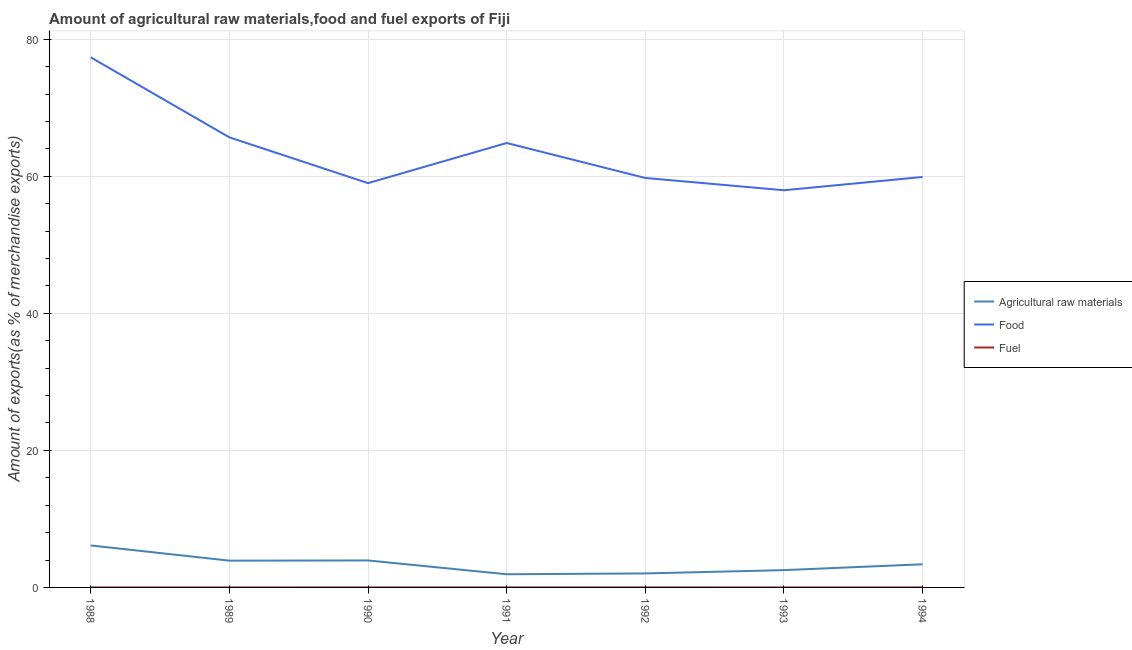How many different coloured lines are there?
Give a very brief answer. 3. Does the line corresponding to percentage of food exports intersect with the line corresponding to percentage of raw materials exports?
Offer a terse response. No. What is the percentage of raw materials exports in 1992?
Keep it short and to the point. 2.04. Across all years, what is the maximum percentage of raw materials exports?
Provide a short and direct response. 6.13. Across all years, what is the minimum percentage of raw materials exports?
Give a very brief answer. 1.92. In which year was the percentage of fuel exports maximum?
Keep it short and to the point. 1991. What is the total percentage of fuel exports in the graph?
Make the answer very short. 0.01. What is the difference between the percentage of fuel exports in 1988 and that in 1993?
Make the answer very short. -0. What is the difference between the percentage of fuel exports in 1988 and the percentage of food exports in 1989?
Provide a succinct answer. -65.68. What is the average percentage of food exports per year?
Provide a short and direct response. 63.5. In the year 1988, what is the difference between the percentage of fuel exports and percentage of raw materials exports?
Your answer should be compact. -6.13. What is the ratio of the percentage of fuel exports in 1988 to that in 1994?
Your answer should be very brief. 0.27. What is the difference between the highest and the second highest percentage of food exports?
Offer a terse response. 11.68. What is the difference between the highest and the lowest percentage of raw materials exports?
Your answer should be very brief. 4.2. Is the sum of the percentage of food exports in 1988 and 1994 greater than the maximum percentage of fuel exports across all years?
Your response must be concise. Yes. How many lines are there?
Give a very brief answer. 3. Are the values on the major ticks of Y-axis written in scientific E-notation?
Provide a succinct answer. No. Does the graph contain any zero values?
Offer a very short reply. No. Does the graph contain grids?
Your response must be concise. Yes. How many legend labels are there?
Offer a terse response. 3. How are the legend labels stacked?
Keep it short and to the point. Vertical. What is the title of the graph?
Give a very brief answer. Amount of agricultural raw materials,food and fuel exports of Fiji. What is the label or title of the X-axis?
Give a very brief answer. Year. What is the label or title of the Y-axis?
Offer a terse response. Amount of exports(as % of merchandise exports). What is the Amount of exports(as % of merchandise exports) of Agricultural raw materials in 1988?
Provide a short and direct response. 6.13. What is the Amount of exports(as % of merchandise exports) of Food in 1988?
Give a very brief answer. 77.36. What is the Amount of exports(as % of merchandise exports) of Fuel in 1988?
Give a very brief answer. 0. What is the Amount of exports(as % of merchandise exports) of Agricultural raw materials in 1989?
Offer a very short reply. 3.91. What is the Amount of exports(as % of merchandise exports) in Food in 1989?
Give a very brief answer. 65.68. What is the Amount of exports(as % of merchandise exports) in Fuel in 1989?
Offer a very short reply. 3.98845700657726e-5. What is the Amount of exports(as % of merchandise exports) in Agricultural raw materials in 1990?
Keep it short and to the point. 3.94. What is the Amount of exports(as % of merchandise exports) of Food in 1990?
Offer a terse response. 59. What is the Amount of exports(as % of merchandise exports) in Fuel in 1990?
Your response must be concise. 0. What is the Amount of exports(as % of merchandise exports) in Agricultural raw materials in 1991?
Your answer should be very brief. 1.92. What is the Amount of exports(as % of merchandise exports) of Food in 1991?
Offer a very short reply. 64.85. What is the Amount of exports(as % of merchandise exports) in Fuel in 1991?
Your answer should be compact. 0. What is the Amount of exports(as % of merchandise exports) of Agricultural raw materials in 1992?
Keep it short and to the point. 2.04. What is the Amount of exports(as % of merchandise exports) in Food in 1992?
Give a very brief answer. 59.75. What is the Amount of exports(as % of merchandise exports) in Fuel in 1992?
Offer a terse response. 0. What is the Amount of exports(as % of merchandise exports) of Agricultural raw materials in 1993?
Offer a very short reply. 2.53. What is the Amount of exports(as % of merchandise exports) in Food in 1993?
Provide a succinct answer. 57.96. What is the Amount of exports(as % of merchandise exports) in Fuel in 1993?
Your answer should be very brief. 0. What is the Amount of exports(as % of merchandise exports) in Agricultural raw materials in 1994?
Keep it short and to the point. 3.38. What is the Amount of exports(as % of merchandise exports) of Food in 1994?
Keep it short and to the point. 59.9. What is the Amount of exports(as % of merchandise exports) in Fuel in 1994?
Make the answer very short. 0. Across all years, what is the maximum Amount of exports(as % of merchandise exports) of Agricultural raw materials?
Your response must be concise. 6.13. Across all years, what is the maximum Amount of exports(as % of merchandise exports) in Food?
Give a very brief answer. 77.36. Across all years, what is the maximum Amount of exports(as % of merchandise exports) in Fuel?
Provide a succinct answer. 0. Across all years, what is the minimum Amount of exports(as % of merchandise exports) of Agricultural raw materials?
Offer a very short reply. 1.92. Across all years, what is the minimum Amount of exports(as % of merchandise exports) in Food?
Provide a short and direct response. 57.96. Across all years, what is the minimum Amount of exports(as % of merchandise exports) of Fuel?
Give a very brief answer. 3.98845700657726e-5. What is the total Amount of exports(as % of merchandise exports) in Agricultural raw materials in the graph?
Keep it short and to the point. 23.84. What is the total Amount of exports(as % of merchandise exports) in Food in the graph?
Give a very brief answer. 444.5. What is the total Amount of exports(as % of merchandise exports) of Fuel in the graph?
Keep it short and to the point. 0.01. What is the difference between the Amount of exports(as % of merchandise exports) in Agricultural raw materials in 1988 and that in 1989?
Your response must be concise. 2.22. What is the difference between the Amount of exports(as % of merchandise exports) of Food in 1988 and that in 1989?
Your answer should be compact. 11.68. What is the difference between the Amount of exports(as % of merchandise exports) in Agricultural raw materials in 1988 and that in 1990?
Provide a succinct answer. 2.19. What is the difference between the Amount of exports(as % of merchandise exports) of Food in 1988 and that in 1990?
Your answer should be very brief. 18.36. What is the difference between the Amount of exports(as % of merchandise exports) in Fuel in 1988 and that in 1990?
Make the answer very short. -0. What is the difference between the Amount of exports(as % of merchandise exports) in Agricultural raw materials in 1988 and that in 1991?
Provide a succinct answer. 4.2. What is the difference between the Amount of exports(as % of merchandise exports) in Food in 1988 and that in 1991?
Keep it short and to the point. 12.5. What is the difference between the Amount of exports(as % of merchandise exports) of Fuel in 1988 and that in 1991?
Provide a succinct answer. -0. What is the difference between the Amount of exports(as % of merchandise exports) of Agricultural raw materials in 1988 and that in 1992?
Offer a very short reply. 4.08. What is the difference between the Amount of exports(as % of merchandise exports) of Food in 1988 and that in 1992?
Your answer should be compact. 17.6. What is the difference between the Amount of exports(as % of merchandise exports) of Fuel in 1988 and that in 1992?
Give a very brief answer. -0. What is the difference between the Amount of exports(as % of merchandise exports) of Agricultural raw materials in 1988 and that in 1993?
Offer a very short reply. 3.6. What is the difference between the Amount of exports(as % of merchandise exports) of Food in 1988 and that in 1993?
Ensure brevity in your answer.  19.4. What is the difference between the Amount of exports(as % of merchandise exports) in Fuel in 1988 and that in 1993?
Your answer should be compact. -0. What is the difference between the Amount of exports(as % of merchandise exports) in Agricultural raw materials in 1988 and that in 1994?
Make the answer very short. 2.75. What is the difference between the Amount of exports(as % of merchandise exports) of Food in 1988 and that in 1994?
Your response must be concise. 17.46. What is the difference between the Amount of exports(as % of merchandise exports) of Fuel in 1988 and that in 1994?
Offer a very short reply. -0. What is the difference between the Amount of exports(as % of merchandise exports) in Agricultural raw materials in 1989 and that in 1990?
Offer a terse response. -0.03. What is the difference between the Amount of exports(as % of merchandise exports) of Food in 1989 and that in 1990?
Make the answer very short. 6.68. What is the difference between the Amount of exports(as % of merchandise exports) of Fuel in 1989 and that in 1990?
Keep it short and to the point. -0. What is the difference between the Amount of exports(as % of merchandise exports) of Agricultural raw materials in 1989 and that in 1991?
Keep it short and to the point. 1.98. What is the difference between the Amount of exports(as % of merchandise exports) in Food in 1989 and that in 1991?
Provide a short and direct response. 0.83. What is the difference between the Amount of exports(as % of merchandise exports) in Fuel in 1989 and that in 1991?
Make the answer very short. -0. What is the difference between the Amount of exports(as % of merchandise exports) in Agricultural raw materials in 1989 and that in 1992?
Offer a very short reply. 1.86. What is the difference between the Amount of exports(as % of merchandise exports) of Food in 1989 and that in 1992?
Your answer should be compact. 5.93. What is the difference between the Amount of exports(as % of merchandise exports) in Fuel in 1989 and that in 1992?
Ensure brevity in your answer.  -0. What is the difference between the Amount of exports(as % of merchandise exports) of Agricultural raw materials in 1989 and that in 1993?
Keep it short and to the point. 1.38. What is the difference between the Amount of exports(as % of merchandise exports) in Food in 1989 and that in 1993?
Your response must be concise. 7.72. What is the difference between the Amount of exports(as % of merchandise exports) in Fuel in 1989 and that in 1993?
Give a very brief answer. -0. What is the difference between the Amount of exports(as % of merchandise exports) in Agricultural raw materials in 1989 and that in 1994?
Keep it short and to the point. 0.53. What is the difference between the Amount of exports(as % of merchandise exports) in Food in 1989 and that in 1994?
Offer a terse response. 5.78. What is the difference between the Amount of exports(as % of merchandise exports) in Fuel in 1989 and that in 1994?
Your answer should be compact. -0. What is the difference between the Amount of exports(as % of merchandise exports) of Agricultural raw materials in 1990 and that in 1991?
Your answer should be very brief. 2.01. What is the difference between the Amount of exports(as % of merchandise exports) of Food in 1990 and that in 1991?
Your response must be concise. -5.86. What is the difference between the Amount of exports(as % of merchandise exports) of Fuel in 1990 and that in 1991?
Give a very brief answer. -0. What is the difference between the Amount of exports(as % of merchandise exports) of Agricultural raw materials in 1990 and that in 1992?
Give a very brief answer. 1.89. What is the difference between the Amount of exports(as % of merchandise exports) in Food in 1990 and that in 1992?
Offer a very short reply. -0.75. What is the difference between the Amount of exports(as % of merchandise exports) in Fuel in 1990 and that in 1992?
Offer a terse response. -0. What is the difference between the Amount of exports(as % of merchandise exports) in Agricultural raw materials in 1990 and that in 1993?
Ensure brevity in your answer.  1.41. What is the difference between the Amount of exports(as % of merchandise exports) of Food in 1990 and that in 1993?
Your answer should be compact. 1.04. What is the difference between the Amount of exports(as % of merchandise exports) in Agricultural raw materials in 1990 and that in 1994?
Your answer should be compact. 0.56. What is the difference between the Amount of exports(as % of merchandise exports) of Food in 1990 and that in 1994?
Offer a very short reply. -0.9. What is the difference between the Amount of exports(as % of merchandise exports) of Agricultural raw materials in 1991 and that in 1992?
Your answer should be compact. -0.12. What is the difference between the Amount of exports(as % of merchandise exports) in Food in 1991 and that in 1992?
Your answer should be very brief. 5.1. What is the difference between the Amount of exports(as % of merchandise exports) of Fuel in 1991 and that in 1992?
Your answer should be very brief. 0. What is the difference between the Amount of exports(as % of merchandise exports) in Agricultural raw materials in 1991 and that in 1993?
Your answer should be compact. -0.6. What is the difference between the Amount of exports(as % of merchandise exports) of Food in 1991 and that in 1993?
Your answer should be very brief. 6.9. What is the difference between the Amount of exports(as % of merchandise exports) in Fuel in 1991 and that in 1993?
Provide a short and direct response. 0. What is the difference between the Amount of exports(as % of merchandise exports) in Agricultural raw materials in 1991 and that in 1994?
Make the answer very short. -1.45. What is the difference between the Amount of exports(as % of merchandise exports) of Food in 1991 and that in 1994?
Your answer should be compact. 4.96. What is the difference between the Amount of exports(as % of merchandise exports) in Fuel in 1991 and that in 1994?
Offer a terse response. 0. What is the difference between the Amount of exports(as % of merchandise exports) in Agricultural raw materials in 1992 and that in 1993?
Offer a very short reply. -0.48. What is the difference between the Amount of exports(as % of merchandise exports) in Food in 1992 and that in 1993?
Keep it short and to the point. 1.79. What is the difference between the Amount of exports(as % of merchandise exports) in Fuel in 1992 and that in 1993?
Offer a very short reply. 0. What is the difference between the Amount of exports(as % of merchandise exports) in Agricultural raw materials in 1992 and that in 1994?
Provide a short and direct response. -1.34. What is the difference between the Amount of exports(as % of merchandise exports) in Food in 1992 and that in 1994?
Offer a terse response. -0.15. What is the difference between the Amount of exports(as % of merchandise exports) in Fuel in 1992 and that in 1994?
Give a very brief answer. 0. What is the difference between the Amount of exports(as % of merchandise exports) of Agricultural raw materials in 1993 and that in 1994?
Offer a very short reply. -0.85. What is the difference between the Amount of exports(as % of merchandise exports) of Food in 1993 and that in 1994?
Provide a short and direct response. -1.94. What is the difference between the Amount of exports(as % of merchandise exports) of Agricultural raw materials in 1988 and the Amount of exports(as % of merchandise exports) of Food in 1989?
Offer a very short reply. -59.55. What is the difference between the Amount of exports(as % of merchandise exports) of Agricultural raw materials in 1988 and the Amount of exports(as % of merchandise exports) of Fuel in 1989?
Give a very brief answer. 6.13. What is the difference between the Amount of exports(as % of merchandise exports) in Food in 1988 and the Amount of exports(as % of merchandise exports) in Fuel in 1989?
Provide a succinct answer. 77.36. What is the difference between the Amount of exports(as % of merchandise exports) of Agricultural raw materials in 1988 and the Amount of exports(as % of merchandise exports) of Food in 1990?
Make the answer very short. -52.87. What is the difference between the Amount of exports(as % of merchandise exports) in Agricultural raw materials in 1988 and the Amount of exports(as % of merchandise exports) in Fuel in 1990?
Make the answer very short. 6.12. What is the difference between the Amount of exports(as % of merchandise exports) of Food in 1988 and the Amount of exports(as % of merchandise exports) of Fuel in 1990?
Keep it short and to the point. 77.35. What is the difference between the Amount of exports(as % of merchandise exports) in Agricultural raw materials in 1988 and the Amount of exports(as % of merchandise exports) in Food in 1991?
Give a very brief answer. -58.73. What is the difference between the Amount of exports(as % of merchandise exports) of Agricultural raw materials in 1988 and the Amount of exports(as % of merchandise exports) of Fuel in 1991?
Your answer should be very brief. 6.12. What is the difference between the Amount of exports(as % of merchandise exports) in Food in 1988 and the Amount of exports(as % of merchandise exports) in Fuel in 1991?
Provide a short and direct response. 77.35. What is the difference between the Amount of exports(as % of merchandise exports) in Agricultural raw materials in 1988 and the Amount of exports(as % of merchandise exports) in Food in 1992?
Make the answer very short. -53.63. What is the difference between the Amount of exports(as % of merchandise exports) in Agricultural raw materials in 1988 and the Amount of exports(as % of merchandise exports) in Fuel in 1992?
Your answer should be very brief. 6.12. What is the difference between the Amount of exports(as % of merchandise exports) of Food in 1988 and the Amount of exports(as % of merchandise exports) of Fuel in 1992?
Keep it short and to the point. 77.35. What is the difference between the Amount of exports(as % of merchandise exports) of Agricultural raw materials in 1988 and the Amount of exports(as % of merchandise exports) of Food in 1993?
Your answer should be compact. -51.83. What is the difference between the Amount of exports(as % of merchandise exports) in Agricultural raw materials in 1988 and the Amount of exports(as % of merchandise exports) in Fuel in 1993?
Provide a succinct answer. 6.12. What is the difference between the Amount of exports(as % of merchandise exports) of Food in 1988 and the Amount of exports(as % of merchandise exports) of Fuel in 1993?
Provide a succinct answer. 77.36. What is the difference between the Amount of exports(as % of merchandise exports) in Agricultural raw materials in 1988 and the Amount of exports(as % of merchandise exports) in Food in 1994?
Your answer should be compact. -53.77. What is the difference between the Amount of exports(as % of merchandise exports) in Agricultural raw materials in 1988 and the Amount of exports(as % of merchandise exports) in Fuel in 1994?
Your response must be concise. 6.12. What is the difference between the Amount of exports(as % of merchandise exports) of Food in 1988 and the Amount of exports(as % of merchandise exports) of Fuel in 1994?
Provide a short and direct response. 77.36. What is the difference between the Amount of exports(as % of merchandise exports) in Agricultural raw materials in 1989 and the Amount of exports(as % of merchandise exports) in Food in 1990?
Your response must be concise. -55.09. What is the difference between the Amount of exports(as % of merchandise exports) in Agricultural raw materials in 1989 and the Amount of exports(as % of merchandise exports) in Fuel in 1990?
Offer a terse response. 3.9. What is the difference between the Amount of exports(as % of merchandise exports) in Food in 1989 and the Amount of exports(as % of merchandise exports) in Fuel in 1990?
Your answer should be compact. 65.68. What is the difference between the Amount of exports(as % of merchandise exports) in Agricultural raw materials in 1989 and the Amount of exports(as % of merchandise exports) in Food in 1991?
Keep it short and to the point. -60.95. What is the difference between the Amount of exports(as % of merchandise exports) in Agricultural raw materials in 1989 and the Amount of exports(as % of merchandise exports) in Fuel in 1991?
Your response must be concise. 3.9. What is the difference between the Amount of exports(as % of merchandise exports) in Food in 1989 and the Amount of exports(as % of merchandise exports) in Fuel in 1991?
Your answer should be very brief. 65.68. What is the difference between the Amount of exports(as % of merchandise exports) of Agricultural raw materials in 1989 and the Amount of exports(as % of merchandise exports) of Food in 1992?
Offer a very short reply. -55.85. What is the difference between the Amount of exports(as % of merchandise exports) of Agricultural raw materials in 1989 and the Amount of exports(as % of merchandise exports) of Fuel in 1992?
Provide a short and direct response. 3.9. What is the difference between the Amount of exports(as % of merchandise exports) of Food in 1989 and the Amount of exports(as % of merchandise exports) of Fuel in 1992?
Provide a short and direct response. 65.68. What is the difference between the Amount of exports(as % of merchandise exports) of Agricultural raw materials in 1989 and the Amount of exports(as % of merchandise exports) of Food in 1993?
Give a very brief answer. -54.05. What is the difference between the Amount of exports(as % of merchandise exports) of Agricultural raw materials in 1989 and the Amount of exports(as % of merchandise exports) of Fuel in 1993?
Ensure brevity in your answer.  3.91. What is the difference between the Amount of exports(as % of merchandise exports) of Food in 1989 and the Amount of exports(as % of merchandise exports) of Fuel in 1993?
Your answer should be compact. 65.68. What is the difference between the Amount of exports(as % of merchandise exports) of Agricultural raw materials in 1989 and the Amount of exports(as % of merchandise exports) of Food in 1994?
Offer a very short reply. -55.99. What is the difference between the Amount of exports(as % of merchandise exports) in Agricultural raw materials in 1989 and the Amount of exports(as % of merchandise exports) in Fuel in 1994?
Provide a short and direct response. 3.91. What is the difference between the Amount of exports(as % of merchandise exports) in Food in 1989 and the Amount of exports(as % of merchandise exports) in Fuel in 1994?
Make the answer very short. 65.68. What is the difference between the Amount of exports(as % of merchandise exports) of Agricultural raw materials in 1990 and the Amount of exports(as % of merchandise exports) of Food in 1991?
Provide a succinct answer. -60.92. What is the difference between the Amount of exports(as % of merchandise exports) of Agricultural raw materials in 1990 and the Amount of exports(as % of merchandise exports) of Fuel in 1991?
Keep it short and to the point. 3.93. What is the difference between the Amount of exports(as % of merchandise exports) in Food in 1990 and the Amount of exports(as % of merchandise exports) in Fuel in 1991?
Provide a short and direct response. 59. What is the difference between the Amount of exports(as % of merchandise exports) in Agricultural raw materials in 1990 and the Amount of exports(as % of merchandise exports) in Food in 1992?
Ensure brevity in your answer.  -55.82. What is the difference between the Amount of exports(as % of merchandise exports) in Agricultural raw materials in 1990 and the Amount of exports(as % of merchandise exports) in Fuel in 1992?
Your response must be concise. 3.93. What is the difference between the Amount of exports(as % of merchandise exports) of Food in 1990 and the Amount of exports(as % of merchandise exports) of Fuel in 1992?
Your answer should be compact. 59. What is the difference between the Amount of exports(as % of merchandise exports) of Agricultural raw materials in 1990 and the Amount of exports(as % of merchandise exports) of Food in 1993?
Offer a very short reply. -54.02. What is the difference between the Amount of exports(as % of merchandise exports) in Agricultural raw materials in 1990 and the Amount of exports(as % of merchandise exports) in Fuel in 1993?
Provide a short and direct response. 3.93. What is the difference between the Amount of exports(as % of merchandise exports) of Food in 1990 and the Amount of exports(as % of merchandise exports) of Fuel in 1993?
Keep it short and to the point. 59. What is the difference between the Amount of exports(as % of merchandise exports) in Agricultural raw materials in 1990 and the Amount of exports(as % of merchandise exports) in Food in 1994?
Your response must be concise. -55.96. What is the difference between the Amount of exports(as % of merchandise exports) in Agricultural raw materials in 1990 and the Amount of exports(as % of merchandise exports) in Fuel in 1994?
Your answer should be very brief. 3.93. What is the difference between the Amount of exports(as % of merchandise exports) in Food in 1990 and the Amount of exports(as % of merchandise exports) in Fuel in 1994?
Offer a very short reply. 59. What is the difference between the Amount of exports(as % of merchandise exports) of Agricultural raw materials in 1991 and the Amount of exports(as % of merchandise exports) of Food in 1992?
Provide a succinct answer. -57.83. What is the difference between the Amount of exports(as % of merchandise exports) of Agricultural raw materials in 1991 and the Amount of exports(as % of merchandise exports) of Fuel in 1992?
Your response must be concise. 1.92. What is the difference between the Amount of exports(as % of merchandise exports) of Food in 1991 and the Amount of exports(as % of merchandise exports) of Fuel in 1992?
Your answer should be very brief. 64.85. What is the difference between the Amount of exports(as % of merchandise exports) of Agricultural raw materials in 1991 and the Amount of exports(as % of merchandise exports) of Food in 1993?
Offer a terse response. -56.03. What is the difference between the Amount of exports(as % of merchandise exports) in Agricultural raw materials in 1991 and the Amount of exports(as % of merchandise exports) in Fuel in 1993?
Your answer should be compact. 1.92. What is the difference between the Amount of exports(as % of merchandise exports) of Food in 1991 and the Amount of exports(as % of merchandise exports) of Fuel in 1993?
Give a very brief answer. 64.85. What is the difference between the Amount of exports(as % of merchandise exports) in Agricultural raw materials in 1991 and the Amount of exports(as % of merchandise exports) in Food in 1994?
Offer a very short reply. -57.97. What is the difference between the Amount of exports(as % of merchandise exports) in Agricultural raw materials in 1991 and the Amount of exports(as % of merchandise exports) in Fuel in 1994?
Provide a succinct answer. 1.92. What is the difference between the Amount of exports(as % of merchandise exports) of Food in 1991 and the Amount of exports(as % of merchandise exports) of Fuel in 1994?
Your response must be concise. 64.85. What is the difference between the Amount of exports(as % of merchandise exports) in Agricultural raw materials in 1992 and the Amount of exports(as % of merchandise exports) in Food in 1993?
Your answer should be compact. -55.92. What is the difference between the Amount of exports(as % of merchandise exports) of Agricultural raw materials in 1992 and the Amount of exports(as % of merchandise exports) of Fuel in 1993?
Your answer should be very brief. 2.04. What is the difference between the Amount of exports(as % of merchandise exports) in Food in 1992 and the Amount of exports(as % of merchandise exports) in Fuel in 1993?
Offer a very short reply. 59.75. What is the difference between the Amount of exports(as % of merchandise exports) in Agricultural raw materials in 1992 and the Amount of exports(as % of merchandise exports) in Food in 1994?
Ensure brevity in your answer.  -57.86. What is the difference between the Amount of exports(as % of merchandise exports) in Agricultural raw materials in 1992 and the Amount of exports(as % of merchandise exports) in Fuel in 1994?
Your answer should be very brief. 2.04. What is the difference between the Amount of exports(as % of merchandise exports) of Food in 1992 and the Amount of exports(as % of merchandise exports) of Fuel in 1994?
Make the answer very short. 59.75. What is the difference between the Amount of exports(as % of merchandise exports) of Agricultural raw materials in 1993 and the Amount of exports(as % of merchandise exports) of Food in 1994?
Offer a terse response. -57.37. What is the difference between the Amount of exports(as % of merchandise exports) in Agricultural raw materials in 1993 and the Amount of exports(as % of merchandise exports) in Fuel in 1994?
Give a very brief answer. 2.52. What is the difference between the Amount of exports(as % of merchandise exports) in Food in 1993 and the Amount of exports(as % of merchandise exports) in Fuel in 1994?
Provide a succinct answer. 57.96. What is the average Amount of exports(as % of merchandise exports) in Agricultural raw materials per year?
Give a very brief answer. 3.41. What is the average Amount of exports(as % of merchandise exports) of Food per year?
Offer a terse response. 63.5. What is the average Amount of exports(as % of merchandise exports) of Fuel per year?
Your answer should be compact. 0. In the year 1988, what is the difference between the Amount of exports(as % of merchandise exports) of Agricultural raw materials and Amount of exports(as % of merchandise exports) of Food?
Offer a very short reply. -71.23. In the year 1988, what is the difference between the Amount of exports(as % of merchandise exports) in Agricultural raw materials and Amount of exports(as % of merchandise exports) in Fuel?
Your response must be concise. 6.13. In the year 1988, what is the difference between the Amount of exports(as % of merchandise exports) in Food and Amount of exports(as % of merchandise exports) in Fuel?
Your answer should be compact. 77.36. In the year 1989, what is the difference between the Amount of exports(as % of merchandise exports) in Agricultural raw materials and Amount of exports(as % of merchandise exports) in Food?
Offer a very short reply. -61.77. In the year 1989, what is the difference between the Amount of exports(as % of merchandise exports) in Agricultural raw materials and Amount of exports(as % of merchandise exports) in Fuel?
Your answer should be compact. 3.91. In the year 1989, what is the difference between the Amount of exports(as % of merchandise exports) of Food and Amount of exports(as % of merchandise exports) of Fuel?
Your response must be concise. 65.68. In the year 1990, what is the difference between the Amount of exports(as % of merchandise exports) in Agricultural raw materials and Amount of exports(as % of merchandise exports) in Food?
Provide a short and direct response. -55.06. In the year 1990, what is the difference between the Amount of exports(as % of merchandise exports) in Agricultural raw materials and Amount of exports(as % of merchandise exports) in Fuel?
Your answer should be very brief. 3.93. In the year 1990, what is the difference between the Amount of exports(as % of merchandise exports) of Food and Amount of exports(as % of merchandise exports) of Fuel?
Your response must be concise. 59. In the year 1991, what is the difference between the Amount of exports(as % of merchandise exports) in Agricultural raw materials and Amount of exports(as % of merchandise exports) in Food?
Make the answer very short. -62.93. In the year 1991, what is the difference between the Amount of exports(as % of merchandise exports) of Agricultural raw materials and Amount of exports(as % of merchandise exports) of Fuel?
Offer a terse response. 1.92. In the year 1991, what is the difference between the Amount of exports(as % of merchandise exports) in Food and Amount of exports(as % of merchandise exports) in Fuel?
Your response must be concise. 64.85. In the year 1992, what is the difference between the Amount of exports(as % of merchandise exports) in Agricultural raw materials and Amount of exports(as % of merchandise exports) in Food?
Your answer should be compact. -57.71. In the year 1992, what is the difference between the Amount of exports(as % of merchandise exports) in Agricultural raw materials and Amount of exports(as % of merchandise exports) in Fuel?
Keep it short and to the point. 2.04. In the year 1992, what is the difference between the Amount of exports(as % of merchandise exports) of Food and Amount of exports(as % of merchandise exports) of Fuel?
Provide a short and direct response. 59.75. In the year 1993, what is the difference between the Amount of exports(as % of merchandise exports) of Agricultural raw materials and Amount of exports(as % of merchandise exports) of Food?
Your answer should be compact. -55.43. In the year 1993, what is the difference between the Amount of exports(as % of merchandise exports) in Agricultural raw materials and Amount of exports(as % of merchandise exports) in Fuel?
Provide a short and direct response. 2.52. In the year 1993, what is the difference between the Amount of exports(as % of merchandise exports) of Food and Amount of exports(as % of merchandise exports) of Fuel?
Your answer should be very brief. 57.96. In the year 1994, what is the difference between the Amount of exports(as % of merchandise exports) in Agricultural raw materials and Amount of exports(as % of merchandise exports) in Food?
Keep it short and to the point. -56.52. In the year 1994, what is the difference between the Amount of exports(as % of merchandise exports) of Agricultural raw materials and Amount of exports(as % of merchandise exports) of Fuel?
Your response must be concise. 3.38. In the year 1994, what is the difference between the Amount of exports(as % of merchandise exports) in Food and Amount of exports(as % of merchandise exports) in Fuel?
Offer a terse response. 59.9. What is the ratio of the Amount of exports(as % of merchandise exports) of Agricultural raw materials in 1988 to that in 1989?
Keep it short and to the point. 1.57. What is the ratio of the Amount of exports(as % of merchandise exports) of Food in 1988 to that in 1989?
Offer a very short reply. 1.18. What is the ratio of the Amount of exports(as % of merchandise exports) in Fuel in 1988 to that in 1989?
Your answer should be very brief. 8.99. What is the ratio of the Amount of exports(as % of merchandise exports) of Agricultural raw materials in 1988 to that in 1990?
Ensure brevity in your answer.  1.56. What is the ratio of the Amount of exports(as % of merchandise exports) of Food in 1988 to that in 1990?
Offer a terse response. 1.31. What is the ratio of the Amount of exports(as % of merchandise exports) of Fuel in 1988 to that in 1990?
Ensure brevity in your answer.  0.15. What is the ratio of the Amount of exports(as % of merchandise exports) of Agricultural raw materials in 1988 to that in 1991?
Ensure brevity in your answer.  3.19. What is the ratio of the Amount of exports(as % of merchandise exports) of Food in 1988 to that in 1991?
Your answer should be compact. 1.19. What is the ratio of the Amount of exports(as % of merchandise exports) in Fuel in 1988 to that in 1991?
Your answer should be very brief. 0.11. What is the ratio of the Amount of exports(as % of merchandise exports) of Agricultural raw materials in 1988 to that in 1992?
Keep it short and to the point. 3. What is the ratio of the Amount of exports(as % of merchandise exports) of Food in 1988 to that in 1992?
Keep it short and to the point. 1.29. What is the ratio of the Amount of exports(as % of merchandise exports) in Fuel in 1988 to that in 1992?
Ensure brevity in your answer.  0.14. What is the ratio of the Amount of exports(as % of merchandise exports) of Agricultural raw materials in 1988 to that in 1993?
Offer a very short reply. 2.43. What is the ratio of the Amount of exports(as % of merchandise exports) of Food in 1988 to that in 1993?
Offer a terse response. 1.33. What is the ratio of the Amount of exports(as % of merchandise exports) of Fuel in 1988 to that in 1993?
Provide a succinct answer. 0.26. What is the ratio of the Amount of exports(as % of merchandise exports) in Agricultural raw materials in 1988 to that in 1994?
Give a very brief answer. 1.81. What is the ratio of the Amount of exports(as % of merchandise exports) in Food in 1988 to that in 1994?
Offer a terse response. 1.29. What is the ratio of the Amount of exports(as % of merchandise exports) of Fuel in 1988 to that in 1994?
Your answer should be compact. 0.27. What is the ratio of the Amount of exports(as % of merchandise exports) of Agricultural raw materials in 1989 to that in 1990?
Your response must be concise. 0.99. What is the ratio of the Amount of exports(as % of merchandise exports) in Food in 1989 to that in 1990?
Provide a succinct answer. 1.11. What is the ratio of the Amount of exports(as % of merchandise exports) in Fuel in 1989 to that in 1990?
Keep it short and to the point. 0.02. What is the ratio of the Amount of exports(as % of merchandise exports) of Agricultural raw materials in 1989 to that in 1991?
Give a very brief answer. 2.03. What is the ratio of the Amount of exports(as % of merchandise exports) in Food in 1989 to that in 1991?
Provide a succinct answer. 1.01. What is the ratio of the Amount of exports(as % of merchandise exports) of Fuel in 1989 to that in 1991?
Your answer should be compact. 0.01. What is the ratio of the Amount of exports(as % of merchandise exports) of Agricultural raw materials in 1989 to that in 1992?
Your response must be concise. 1.91. What is the ratio of the Amount of exports(as % of merchandise exports) of Food in 1989 to that in 1992?
Keep it short and to the point. 1.1. What is the ratio of the Amount of exports(as % of merchandise exports) of Fuel in 1989 to that in 1992?
Make the answer very short. 0.02. What is the ratio of the Amount of exports(as % of merchandise exports) of Agricultural raw materials in 1989 to that in 1993?
Provide a short and direct response. 1.55. What is the ratio of the Amount of exports(as % of merchandise exports) in Food in 1989 to that in 1993?
Give a very brief answer. 1.13. What is the ratio of the Amount of exports(as % of merchandise exports) of Fuel in 1989 to that in 1993?
Your response must be concise. 0.03. What is the ratio of the Amount of exports(as % of merchandise exports) of Agricultural raw materials in 1989 to that in 1994?
Give a very brief answer. 1.16. What is the ratio of the Amount of exports(as % of merchandise exports) of Food in 1989 to that in 1994?
Your answer should be compact. 1.1. What is the ratio of the Amount of exports(as % of merchandise exports) in Fuel in 1989 to that in 1994?
Offer a very short reply. 0.03. What is the ratio of the Amount of exports(as % of merchandise exports) of Agricultural raw materials in 1990 to that in 1991?
Make the answer very short. 2.05. What is the ratio of the Amount of exports(as % of merchandise exports) in Food in 1990 to that in 1991?
Ensure brevity in your answer.  0.91. What is the ratio of the Amount of exports(as % of merchandise exports) of Fuel in 1990 to that in 1991?
Give a very brief answer. 0.71. What is the ratio of the Amount of exports(as % of merchandise exports) in Agricultural raw materials in 1990 to that in 1992?
Provide a succinct answer. 1.93. What is the ratio of the Amount of exports(as % of merchandise exports) in Food in 1990 to that in 1992?
Your answer should be compact. 0.99. What is the ratio of the Amount of exports(as % of merchandise exports) of Fuel in 1990 to that in 1992?
Keep it short and to the point. 0.94. What is the ratio of the Amount of exports(as % of merchandise exports) in Agricultural raw materials in 1990 to that in 1993?
Ensure brevity in your answer.  1.56. What is the ratio of the Amount of exports(as % of merchandise exports) of Fuel in 1990 to that in 1993?
Offer a very short reply. 1.71. What is the ratio of the Amount of exports(as % of merchandise exports) of Agricultural raw materials in 1990 to that in 1994?
Offer a terse response. 1.17. What is the ratio of the Amount of exports(as % of merchandise exports) of Food in 1990 to that in 1994?
Keep it short and to the point. 0.98. What is the ratio of the Amount of exports(as % of merchandise exports) of Fuel in 1990 to that in 1994?
Ensure brevity in your answer.  1.77. What is the ratio of the Amount of exports(as % of merchandise exports) in Agricultural raw materials in 1991 to that in 1992?
Keep it short and to the point. 0.94. What is the ratio of the Amount of exports(as % of merchandise exports) in Food in 1991 to that in 1992?
Keep it short and to the point. 1.09. What is the ratio of the Amount of exports(as % of merchandise exports) in Fuel in 1991 to that in 1992?
Your answer should be very brief. 1.34. What is the ratio of the Amount of exports(as % of merchandise exports) in Agricultural raw materials in 1991 to that in 1993?
Ensure brevity in your answer.  0.76. What is the ratio of the Amount of exports(as % of merchandise exports) of Food in 1991 to that in 1993?
Your response must be concise. 1.12. What is the ratio of the Amount of exports(as % of merchandise exports) of Fuel in 1991 to that in 1993?
Your answer should be very brief. 2.43. What is the ratio of the Amount of exports(as % of merchandise exports) in Agricultural raw materials in 1991 to that in 1994?
Your answer should be very brief. 0.57. What is the ratio of the Amount of exports(as % of merchandise exports) in Food in 1991 to that in 1994?
Provide a succinct answer. 1.08. What is the ratio of the Amount of exports(as % of merchandise exports) in Fuel in 1991 to that in 1994?
Offer a very short reply. 2.51. What is the ratio of the Amount of exports(as % of merchandise exports) in Agricultural raw materials in 1992 to that in 1993?
Your answer should be compact. 0.81. What is the ratio of the Amount of exports(as % of merchandise exports) of Food in 1992 to that in 1993?
Offer a terse response. 1.03. What is the ratio of the Amount of exports(as % of merchandise exports) in Fuel in 1992 to that in 1993?
Your answer should be very brief. 1.81. What is the ratio of the Amount of exports(as % of merchandise exports) of Agricultural raw materials in 1992 to that in 1994?
Give a very brief answer. 0.6. What is the ratio of the Amount of exports(as % of merchandise exports) of Food in 1992 to that in 1994?
Make the answer very short. 1. What is the ratio of the Amount of exports(as % of merchandise exports) of Fuel in 1992 to that in 1994?
Your answer should be compact. 1.88. What is the ratio of the Amount of exports(as % of merchandise exports) of Agricultural raw materials in 1993 to that in 1994?
Offer a very short reply. 0.75. What is the ratio of the Amount of exports(as % of merchandise exports) of Food in 1993 to that in 1994?
Offer a terse response. 0.97. What is the ratio of the Amount of exports(as % of merchandise exports) of Fuel in 1993 to that in 1994?
Provide a succinct answer. 1.03. What is the difference between the highest and the second highest Amount of exports(as % of merchandise exports) of Agricultural raw materials?
Make the answer very short. 2.19. What is the difference between the highest and the second highest Amount of exports(as % of merchandise exports) of Food?
Offer a terse response. 11.68. What is the difference between the highest and the second highest Amount of exports(as % of merchandise exports) in Fuel?
Give a very brief answer. 0. What is the difference between the highest and the lowest Amount of exports(as % of merchandise exports) of Agricultural raw materials?
Provide a short and direct response. 4.2. What is the difference between the highest and the lowest Amount of exports(as % of merchandise exports) of Food?
Offer a terse response. 19.4. What is the difference between the highest and the lowest Amount of exports(as % of merchandise exports) in Fuel?
Give a very brief answer. 0. 